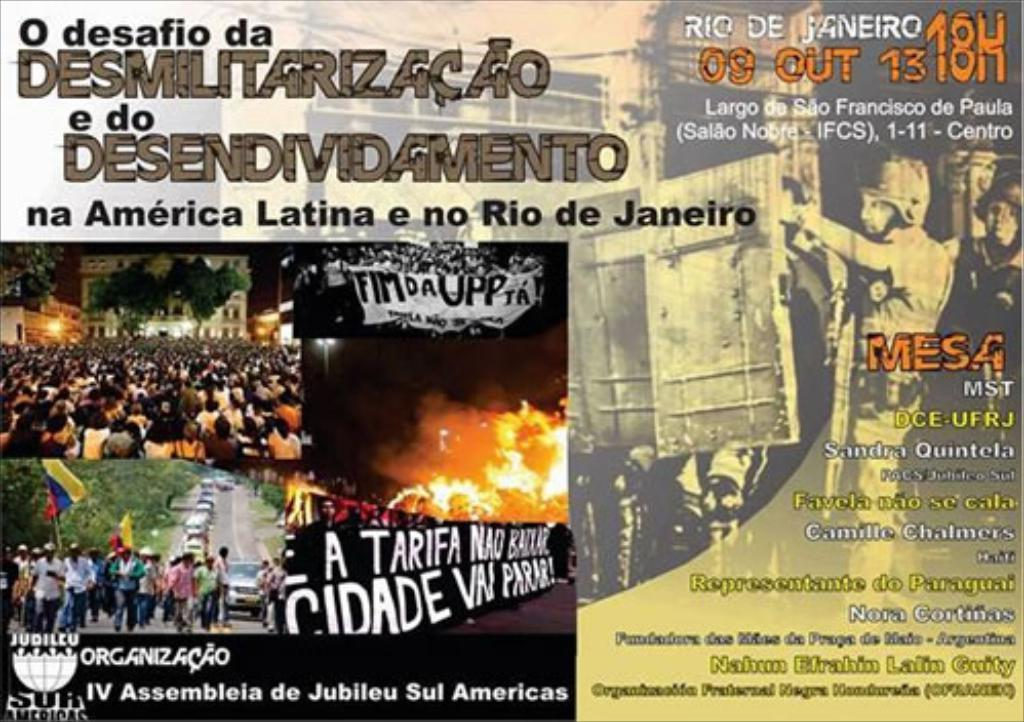<image>
Render a clear and concise summary of the photo. a flyer for "O desafio da Desmilitarizacao" in Rio de Janeiro 